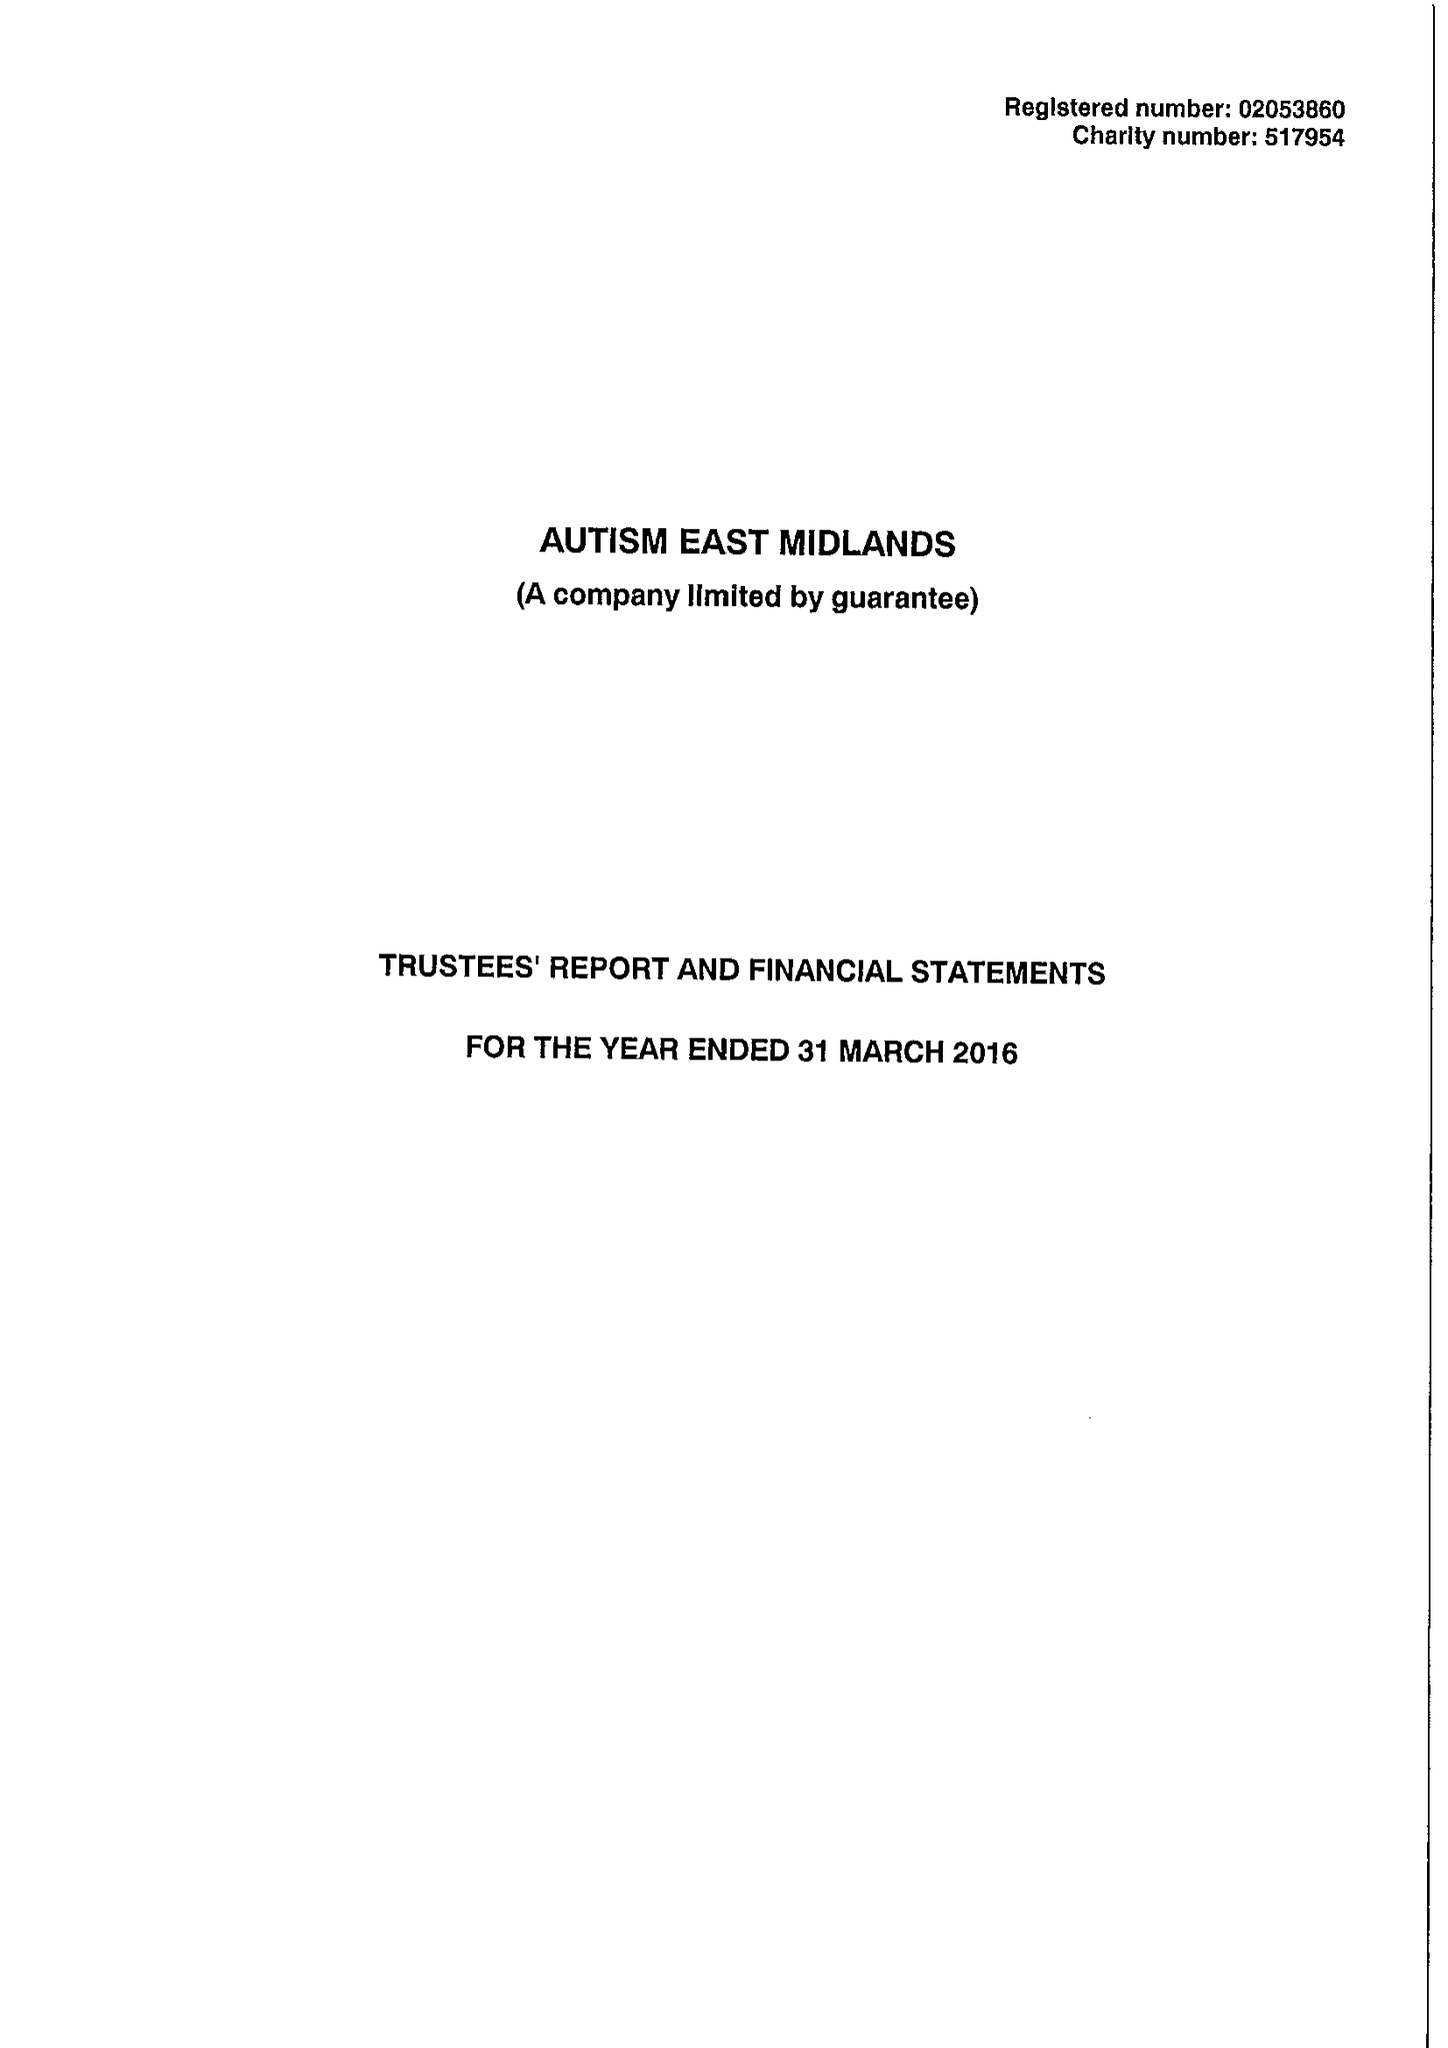What is the value for the charity_number?
Answer the question using a single word or phrase. 517954 